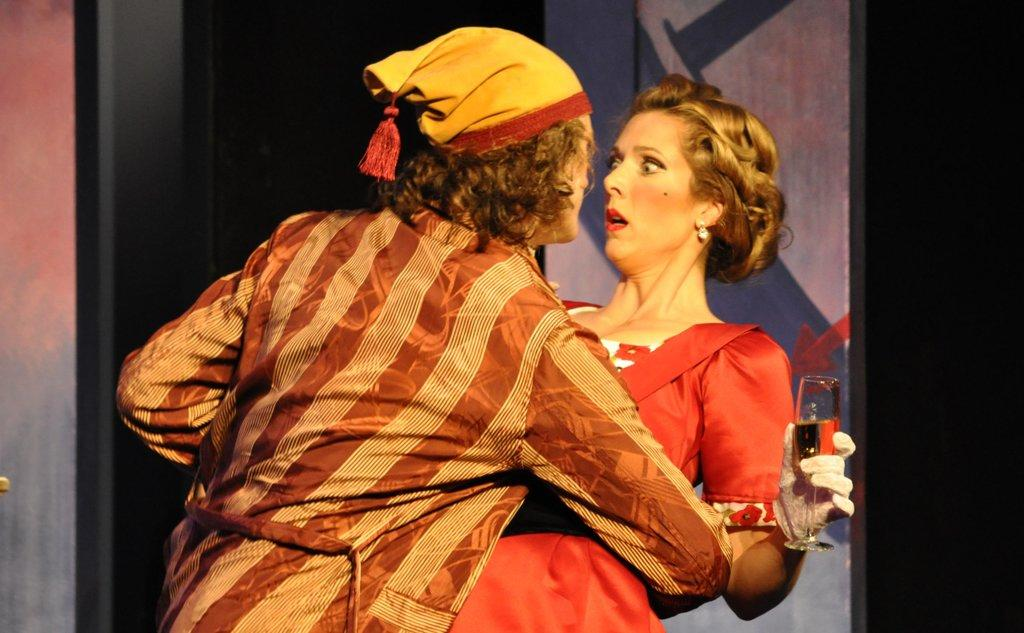Who are the people in the image? There is a man and a lady in the image. What is the lady holding in the image? The lady is holding a glass in the image. What can be seen in the background of the image? There is a board in the background of the image. Where is the squirrel sleeping in the image? There is no squirrel present in the image. What type of food is the lady cooking in the image? The image does not show the lady cooking any food. 